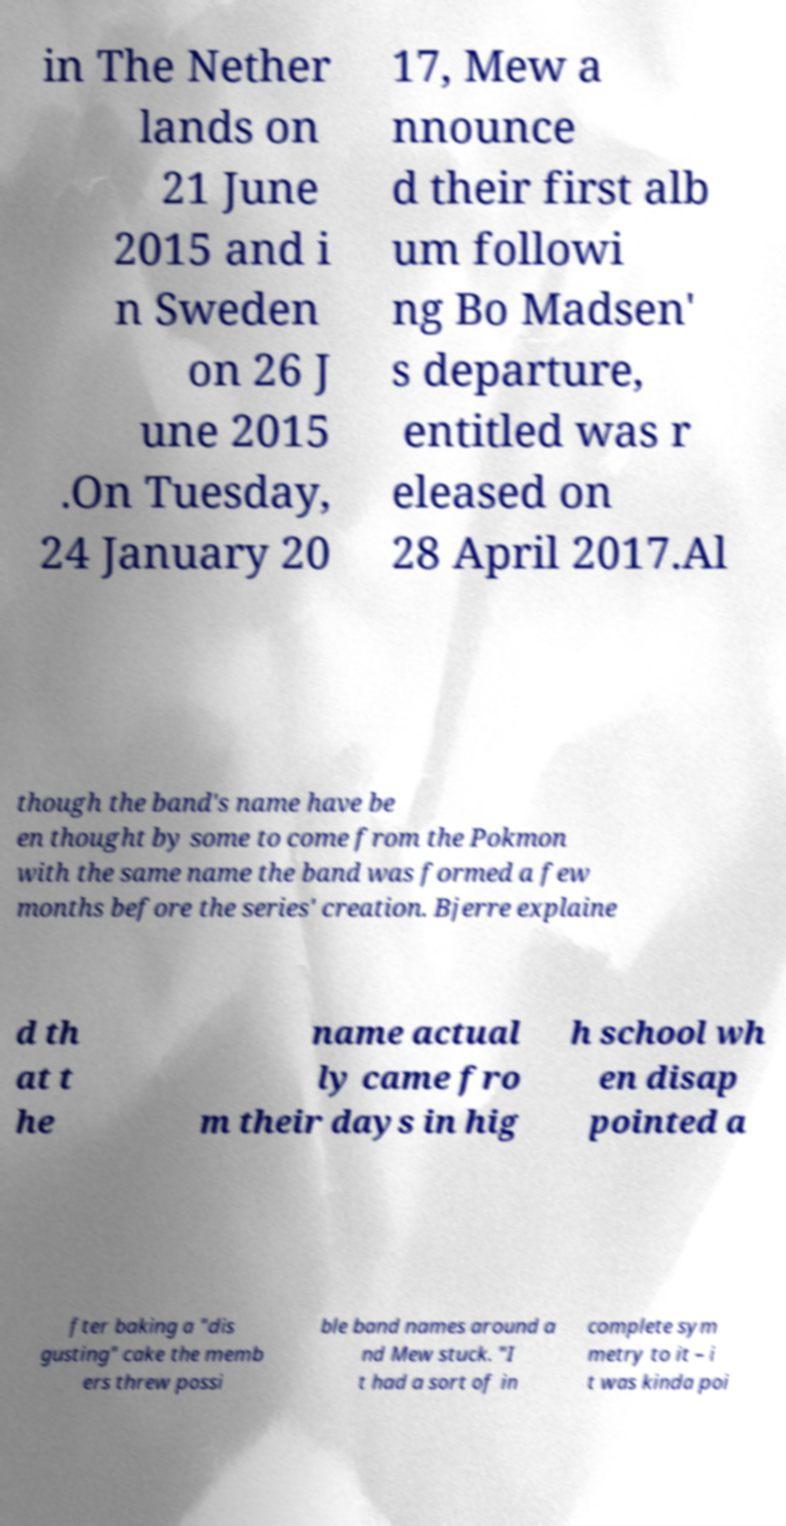I need the written content from this picture converted into text. Can you do that? in The Nether lands on 21 June 2015 and i n Sweden on 26 J une 2015 .On Tuesday, 24 January 20 17, Mew a nnounce d their first alb um followi ng Bo Madsen' s departure, entitled was r eleased on 28 April 2017.Al though the band's name have be en thought by some to come from the Pokmon with the same name the band was formed a few months before the series' creation. Bjerre explaine d th at t he name actual ly came fro m their days in hig h school wh en disap pointed a fter baking a "dis gusting" cake the memb ers threw possi ble band names around a nd Mew stuck. "I t had a sort of in complete sym metry to it – i t was kinda poi 